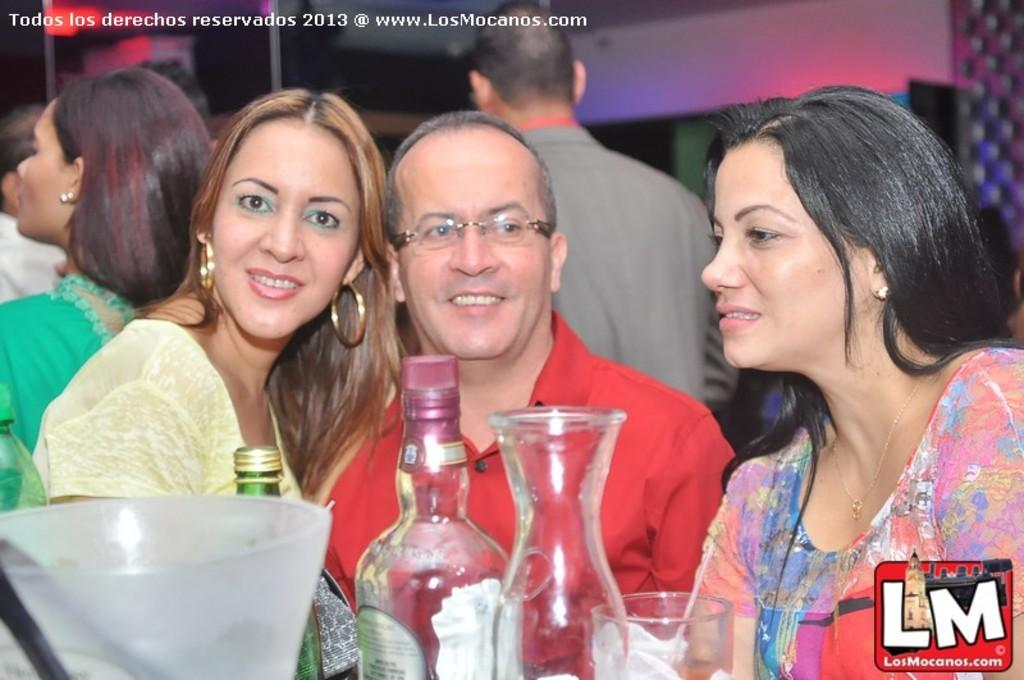What objects are located in the front of the image? There are bottles and a glass in the front of the image. What are the persons in the image doing? The persons are standing in the center of the image and smiling. What can be seen in the background of the image? There is a wall and lights in the background of the image. What type of frame is visible around the persons in the image? There is no frame visible around the persons in the image. What is the weather like in the image? The provided facts do not mention any information about the weather in the image. 